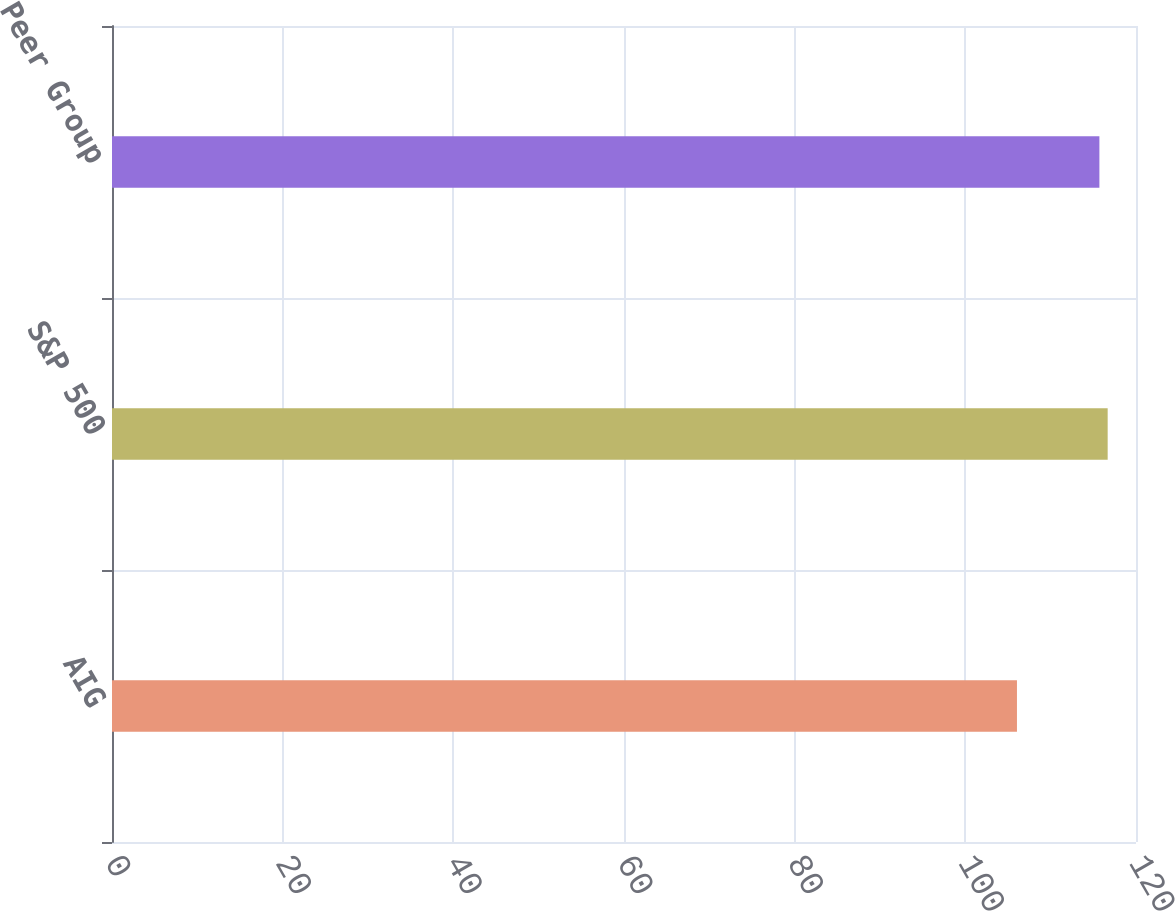<chart> <loc_0><loc_0><loc_500><loc_500><bar_chart><fcel>AIG<fcel>S&P 500<fcel>Peer Group<nl><fcel>106.05<fcel>116.68<fcel>115.71<nl></chart> 